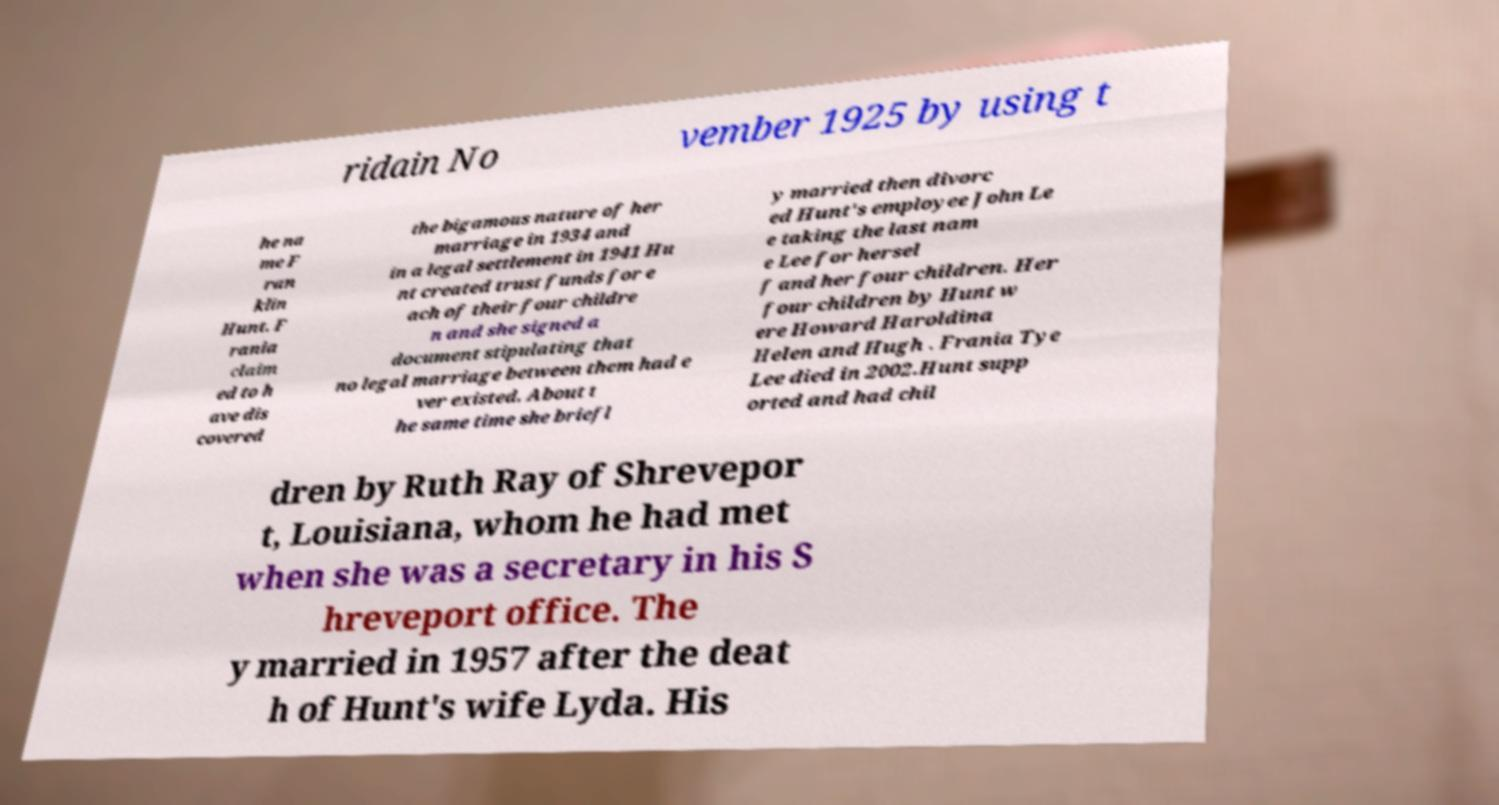There's text embedded in this image that I need extracted. Can you transcribe it verbatim? ridain No vember 1925 by using t he na me F ran klin Hunt. F rania claim ed to h ave dis covered the bigamous nature of her marriage in 1934 and in a legal settlement in 1941 Hu nt created trust funds for e ach of their four childre n and she signed a document stipulating that no legal marriage between them had e ver existed. About t he same time she briefl y married then divorc ed Hunt's employee John Le e taking the last nam e Lee for hersel f and her four children. Her four children by Hunt w ere Howard Haroldina Helen and Hugh . Frania Tye Lee died in 2002.Hunt supp orted and had chil dren by Ruth Ray of Shrevepor t, Louisiana, whom he had met when she was a secretary in his S hreveport office. The y married in 1957 after the deat h of Hunt's wife Lyda. His 